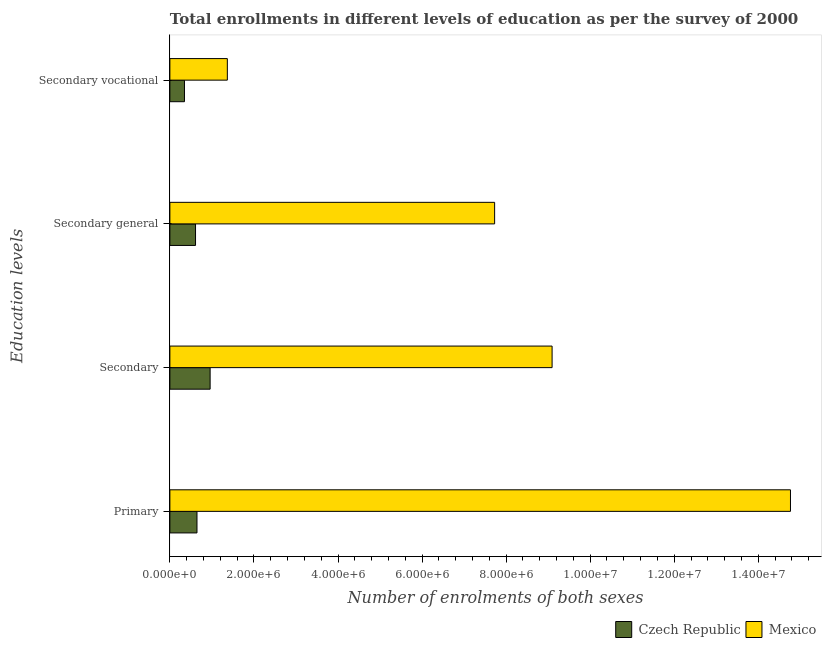Are the number of bars per tick equal to the number of legend labels?
Keep it short and to the point. Yes. How many bars are there on the 3rd tick from the top?
Ensure brevity in your answer.  2. How many bars are there on the 3rd tick from the bottom?
Provide a succinct answer. 2. What is the label of the 1st group of bars from the top?
Your answer should be compact. Secondary vocational. What is the number of enrolments in secondary general education in Czech Republic?
Provide a succinct answer. 6.10e+05. Across all countries, what is the maximum number of enrolments in secondary general education?
Your answer should be very brief. 7.73e+06. Across all countries, what is the minimum number of enrolments in secondary general education?
Your answer should be very brief. 6.10e+05. In which country was the number of enrolments in primary education maximum?
Your response must be concise. Mexico. In which country was the number of enrolments in secondary education minimum?
Your response must be concise. Czech Republic. What is the total number of enrolments in secondary general education in the graph?
Your answer should be very brief. 8.34e+06. What is the difference between the number of enrolments in secondary vocational education in Mexico and that in Czech Republic?
Your answer should be compact. 1.02e+06. What is the difference between the number of enrolments in secondary vocational education in Mexico and the number of enrolments in secondary education in Czech Republic?
Make the answer very short. 4.09e+05. What is the average number of enrolments in secondary general education per country?
Give a very brief answer. 4.17e+06. What is the difference between the number of enrolments in secondary vocational education and number of enrolments in secondary education in Czech Republic?
Offer a very short reply. -6.10e+05. What is the ratio of the number of enrolments in secondary education in Czech Republic to that in Mexico?
Provide a short and direct response. 0.11. Is the number of enrolments in secondary vocational education in Czech Republic less than that in Mexico?
Ensure brevity in your answer.  Yes. What is the difference between the highest and the second highest number of enrolments in secondary education?
Provide a succinct answer. 8.14e+06. What is the difference between the highest and the lowest number of enrolments in secondary general education?
Provide a succinct answer. 7.12e+06. In how many countries, is the number of enrolments in primary education greater than the average number of enrolments in primary education taken over all countries?
Provide a succinct answer. 1. Is the sum of the number of enrolments in primary education in Mexico and Czech Republic greater than the maximum number of enrolments in secondary education across all countries?
Your answer should be very brief. Yes. Is it the case that in every country, the sum of the number of enrolments in secondary general education and number of enrolments in primary education is greater than the sum of number of enrolments in secondary vocational education and number of enrolments in secondary education?
Offer a very short reply. No. What does the 1st bar from the top in Secondary general represents?
Provide a succinct answer. Mexico. What does the 1st bar from the bottom in Secondary general represents?
Provide a short and direct response. Czech Republic. Are all the bars in the graph horizontal?
Your answer should be very brief. Yes. What is the difference between two consecutive major ticks on the X-axis?
Offer a very short reply. 2.00e+06. How are the legend labels stacked?
Provide a short and direct response. Horizontal. What is the title of the graph?
Ensure brevity in your answer.  Total enrollments in different levels of education as per the survey of 2000. What is the label or title of the X-axis?
Make the answer very short. Number of enrolments of both sexes. What is the label or title of the Y-axis?
Provide a succinct answer. Education levels. What is the Number of enrolments of both sexes in Czech Republic in Primary?
Ensure brevity in your answer.  6.45e+05. What is the Number of enrolments of both sexes of Mexico in Primary?
Your response must be concise. 1.48e+07. What is the Number of enrolments of both sexes in Czech Republic in Secondary?
Keep it short and to the point. 9.58e+05. What is the Number of enrolments of both sexes in Mexico in Secondary?
Make the answer very short. 9.09e+06. What is the Number of enrolments of both sexes in Czech Republic in Secondary general?
Give a very brief answer. 6.10e+05. What is the Number of enrolments of both sexes of Mexico in Secondary general?
Your answer should be very brief. 7.73e+06. What is the Number of enrolments of both sexes in Czech Republic in Secondary vocational?
Keep it short and to the point. 3.47e+05. What is the Number of enrolments of both sexes in Mexico in Secondary vocational?
Offer a very short reply. 1.37e+06. Across all Education levels, what is the maximum Number of enrolments of both sexes in Czech Republic?
Offer a terse response. 9.58e+05. Across all Education levels, what is the maximum Number of enrolments of both sexes of Mexico?
Your response must be concise. 1.48e+07. Across all Education levels, what is the minimum Number of enrolments of both sexes in Czech Republic?
Offer a terse response. 3.47e+05. Across all Education levels, what is the minimum Number of enrolments of both sexes of Mexico?
Ensure brevity in your answer.  1.37e+06. What is the total Number of enrolments of both sexes of Czech Republic in the graph?
Your answer should be very brief. 2.56e+06. What is the total Number of enrolments of both sexes of Mexico in the graph?
Provide a short and direct response. 3.30e+07. What is the difference between the Number of enrolments of both sexes in Czech Republic in Primary and that in Secondary?
Your answer should be compact. -3.13e+05. What is the difference between the Number of enrolments of both sexes of Mexico in Primary and that in Secondary?
Give a very brief answer. 5.67e+06. What is the difference between the Number of enrolments of both sexes of Czech Republic in Primary and that in Secondary general?
Provide a succinct answer. 3.45e+04. What is the difference between the Number of enrolments of both sexes in Mexico in Primary and that in Secondary general?
Give a very brief answer. 7.04e+06. What is the difference between the Number of enrolments of both sexes in Czech Republic in Primary and that in Secondary vocational?
Keep it short and to the point. 2.98e+05. What is the difference between the Number of enrolments of both sexes of Mexico in Primary and that in Secondary vocational?
Offer a terse response. 1.34e+07. What is the difference between the Number of enrolments of both sexes in Czech Republic in Secondary and that in Secondary general?
Provide a short and direct response. 3.47e+05. What is the difference between the Number of enrolments of both sexes of Mexico in Secondary and that in Secondary general?
Keep it short and to the point. 1.37e+06. What is the difference between the Number of enrolments of both sexes of Czech Republic in Secondary and that in Secondary vocational?
Give a very brief answer. 6.10e+05. What is the difference between the Number of enrolments of both sexes in Mexico in Secondary and that in Secondary vocational?
Offer a terse response. 7.73e+06. What is the difference between the Number of enrolments of both sexes in Czech Republic in Secondary general and that in Secondary vocational?
Provide a succinct answer. 2.63e+05. What is the difference between the Number of enrolments of both sexes of Mexico in Secondary general and that in Secondary vocational?
Your answer should be compact. 6.36e+06. What is the difference between the Number of enrolments of both sexes in Czech Republic in Primary and the Number of enrolments of both sexes in Mexico in Secondary?
Your response must be concise. -8.45e+06. What is the difference between the Number of enrolments of both sexes of Czech Republic in Primary and the Number of enrolments of both sexes of Mexico in Secondary general?
Ensure brevity in your answer.  -7.08e+06. What is the difference between the Number of enrolments of both sexes in Czech Republic in Primary and the Number of enrolments of both sexes in Mexico in Secondary vocational?
Your answer should be very brief. -7.22e+05. What is the difference between the Number of enrolments of both sexes of Czech Republic in Secondary and the Number of enrolments of both sexes of Mexico in Secondary general?
Your answer should be very brief. -6.77e+06. What is the difference between the Number of enrolments of both sexes of Czech Republic in Secondary and the Number of enrolments of both sexes of Mexico in Secondary vocational?
Your answer should be compact. -4.09e+05. What is the difference between the Number of enrolments of both sexes of Czech Republic in Secondary general and the Number of enrolments of both sexes of Mexico in Secondary vocational?
Your answer should be very brief. -7.57e+05. What is the average Number of enrolments of both sexes in Czech Republic per Education levels?
Keep it short and to the point. 6.40e+05. What is the average Number of enrolments of both sexes in Mexico per Education levels?
Make the answer very short. 8.24e+06. What is the difference between the Number of enrolments of both sexes of Czech Republic and Number of enrolments of both sexes of Mexico in Primary?
Offer a terse response. -1.41e+07. What is the difference between the Number of enrolments of both sexes of Czech Republic and Number of enrolments of both sexes of Mexico in Secondary?
Give a very brief answer. -8.14e+06. What is the difference between the Number of enrolments of both sexes of Czech Republic and Number of enrolments of both sexes of Mexico in Secondary general?
Keep it short and to the point. -7.12e+06. What is the difference between the Number of enrolments of both sexes of Czech Republic and Number of enrolments of both sexes of Mexico in Secondary vocational?
Make the answer very short. -1.02e+06. What is the ratio of the Number of enrolments of both sexes of Czech Republic in Primary to that in Secondary?
Ensure brevity in your answer.  0.67. What is the ratio of the Number of enrolments of both sexes of Mexico in Primary to that in Secondary?
Provide a short and direct response. 1.62. What is the ratio of the Number of enrolments of both sexes of Czech Republic in Primary to that in Secondary general?
Make the answer very short. 1.06. What is the ratio of the Number of enrolments of both sexes in Mexico in Primary to that in Secondary general?
Offer a terse response. 1.91. What is the ratio of the Number of enrolments of both sexes of Czech Republic in Primary to that in Secondary vocational?
Ensure brevity in your answer.  1.86. What is the ratio of the Number of enrolments of both sexes of Mexico in Primary to that in Secondary vocational?
Your response must be concise. 10.8. What is the ratio of the Number of enrolments of both sexes in Czech Republic in Secondary to that in Secondary general?
Offer a terse response. 1.57. What is the ratio of the Number of enrolments of both sexes of Mexico in Secondary to that in Secondary general?
Make the answer very short. 1.18. What is the ratio of the Number of enrolments of both sexes in Czech Republic in Secondary to that in Secondary vocational?
Keep it short and to the point. 2.76. What is the ratio of the Number of enrolments of both sexes in Mexico in Secondary to that in Secondary vocational?
Provide a succinct answer. 6.65. What is the ratio of the Number of enrolments of both sexes of Czech Republic in Secondary general to that in Secondary vocational?
Your answer should be compact. 1.76. What is the ratio of the Number of enrolments of both sexes in Mexico in Secondary general to that in Secondary vocational?
Keep it short and to the point. 5.65. What is the difference between the highest and the second highest Number of enrolments of both sexes of Czech Republic?
Your answer should be compact. 3.13e+05. What is the difference between the highest and the second highest Number of enrolments of both sexes of Mexico?
Keep it short and to the point. 5.67e+06. What is the difference between the highest and the lowest Number of enrolments of both sexes of Czech Republic?
Ensure brevity in your answer.  6.10e+05. What is the difference between the highest and the lowest Number of enrolments of both sexes in Mexico?
Your answer should be very brief. 1.34e+07. 